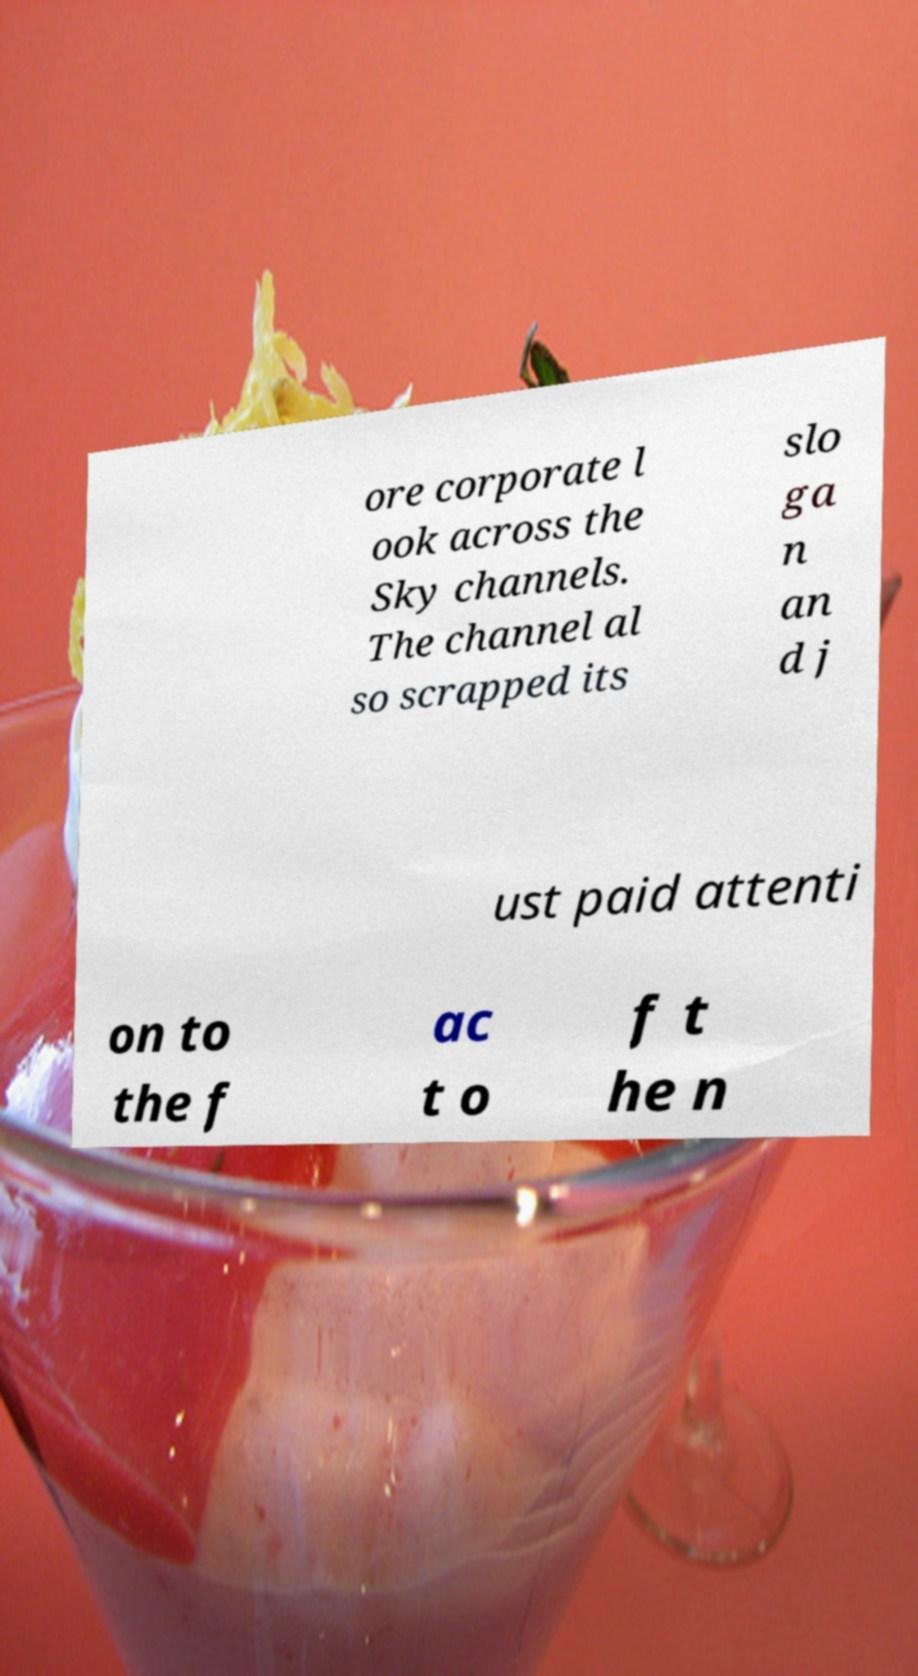Can you read and provide the text displayed in the image?This photo seems to have some interesting text. Can you extract and type it out for me? ore corporate l ook across the Sky channels. The channel al so scrapped its slo ga n an d j ust paid attenti on to the f ac t o f t he n 